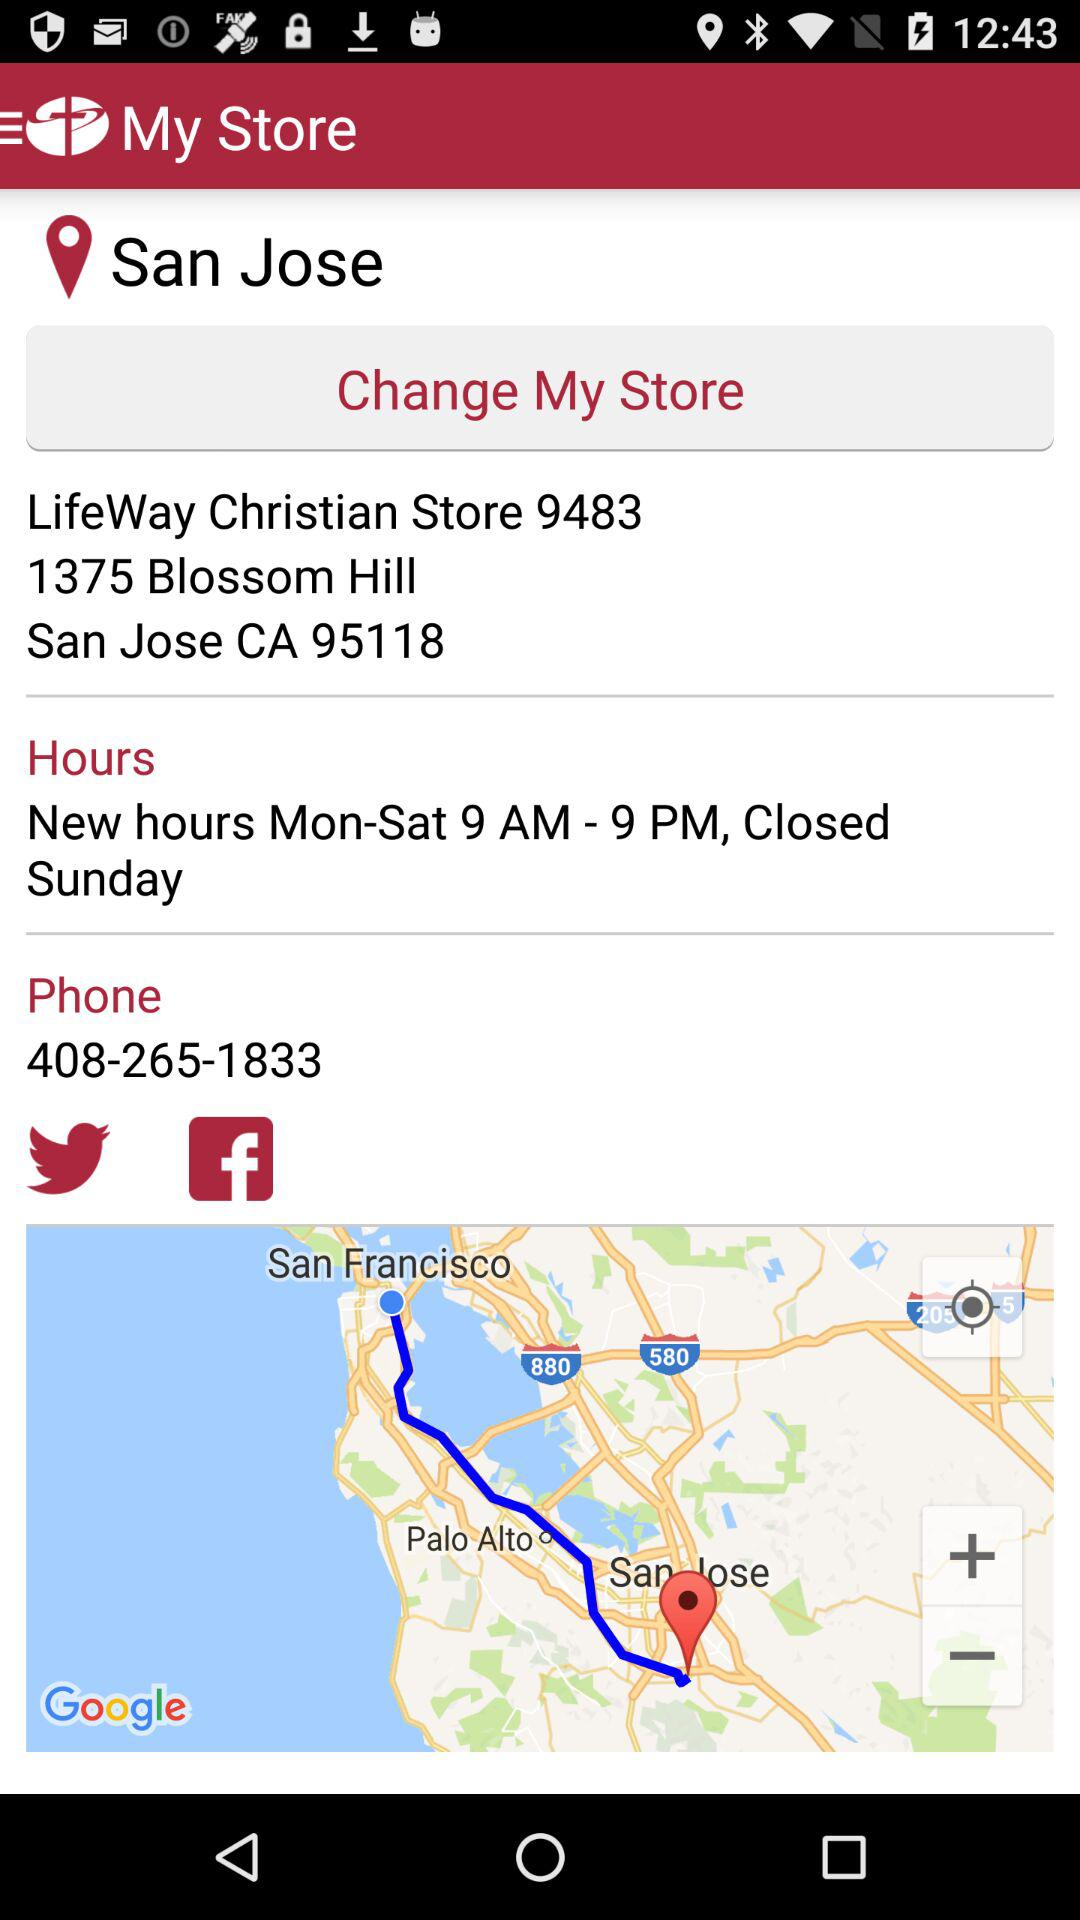How many miles away is the store?
When the provided information is insufficient, respond with <no answer>. <no answer> 